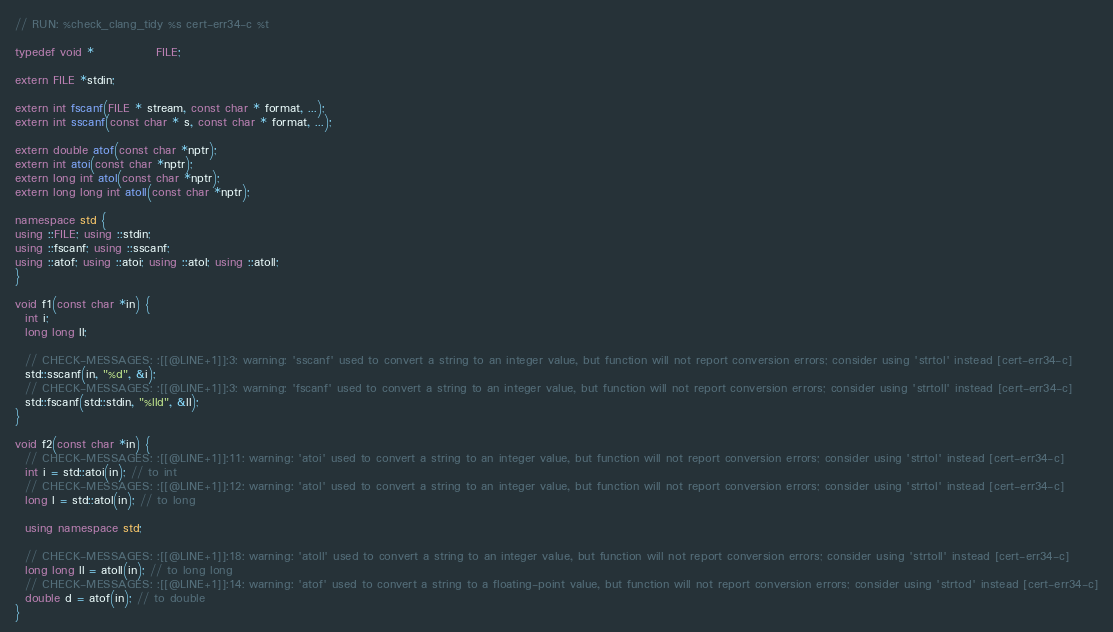<code> <loc_0><loc_0><loc_500><loc_500><_C++_>// RUN: %check_clang_tidy %s cert-err34-c %t

typedef void *             FILE;

extern FILE *stdin;

extern int fscanf(FILE * stream, const char * format, ...);
extern int sscanf(const char * s, const char * format, ...);

extern double atof(const char *nptr);
extern int atoi(const char *nptr);
extern long int atol(const char *nptr);
extern long long int atoll(const char *nptr);

namespace std {
using ::FILE; using ::stdin;
using ::fscanf; using ::sscanf;
using ::atof; using ::atoi; using ::atol; using ::atoll;
}

void f1(const char *in) {
  int i;
  long long ll;

  // CHECK-MESSAGES: :[[@LINE+1]]:3: warning: 'sscanf' used to convert a string to an integer value, but function will not report conversion errors; consider using 'strtol' instead [cert-err34-c]
  std::sscanf(in, "%d", &i);
  // CHECK-MESSAGES: :[[@LINE+1]]:3: warning: 'fscanf' used to convert a string to an integer value, but function will not report conversion errors; consider using 'strtoll' instead [cert-err34-c]
  std::fscanf(std::stdin, "%lld", &ll);
}

void f2(const char *in) {
  // CHECK-MESSAGES: :[[@LINE+1]]:11: warning: 'atoi' used to convert a string to an integer value, but function will not report conversion errors; consider using 'strtol' instead [cert-err34-c]
  int i = std::atoi(in); // to int
  // CHECK-MESSAGES: :[[@LINE+1]]:12: warning: 'atol' used to convert a string to an integer value, but function will not report conversion errors; consider using 'strtol' instead [cert-err34-c]
  long l = std::atol(in); // to long

  using namespace std;

  // CHECK-MESSAGES: :[[@LINE+1]]:18: warning: 'atoll' used to convert a string to an integer value, but function will not report conversion errors; consider using 'strtoll' instead [cert-err34-c]
  long long ll = atoll(in); // to long long
  // CHECK-MESSAGES: :[[@LINE+1]]:14: warning: 'atof' used to convert a string to a floating-point value, but function will not report conversion errors; consider using 'strtod' instead [cert-err34-c]
  double d = atof(in); // to double
}
</code> 